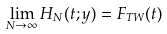Convert formula to latex. <formula><loc_0><loc_0><loc_500><loc_500>\lim _ { N \to \infty } H _ { N } ( t ; y ) = F _ { T W } ( t )</formula> 